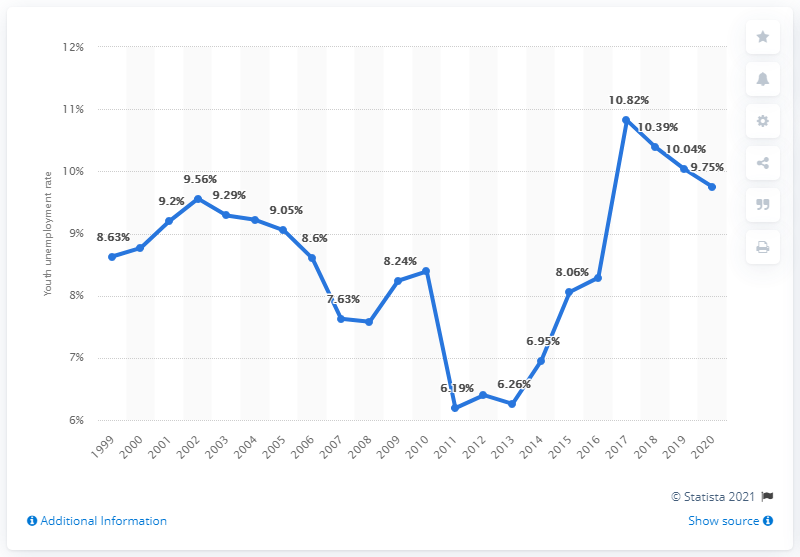Identify some key points in this picture. In 2020, the youth unemployment rate in Panama was 9.75%. 